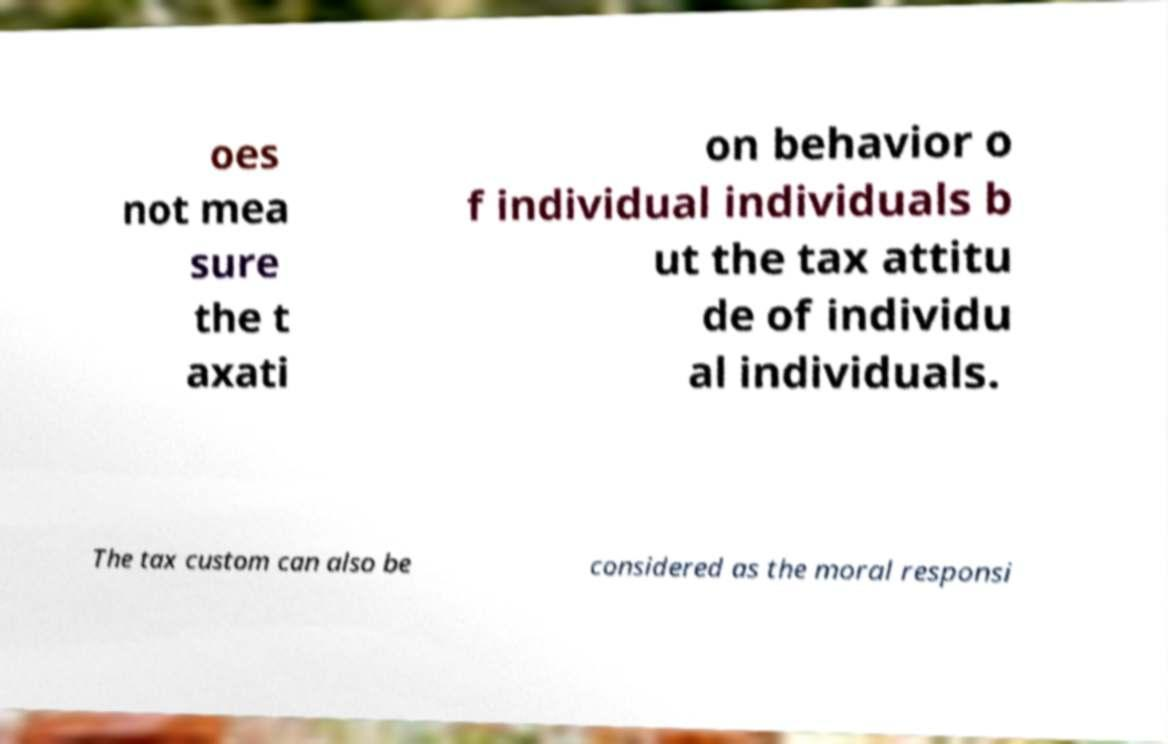Can you read and provide the text displayed in the image?This photo seems to have some interesting text. Can you extract and type it out for me? oes not mea sure the t axati on behavior o f individual individuals b ut the tax attitu de of individu al individuals. The tax custom can also be considered as the moral responsi 